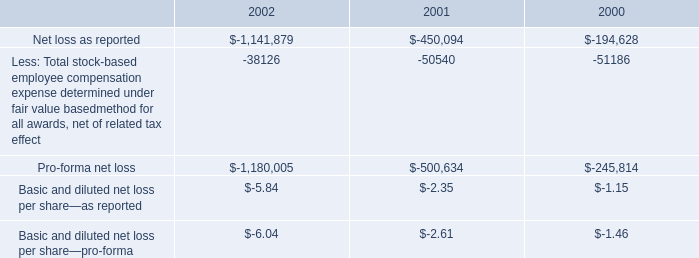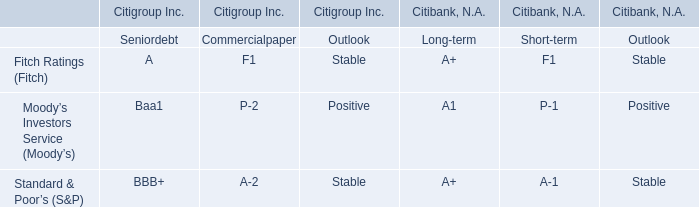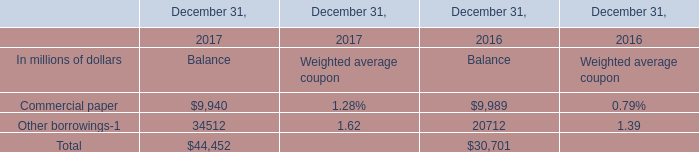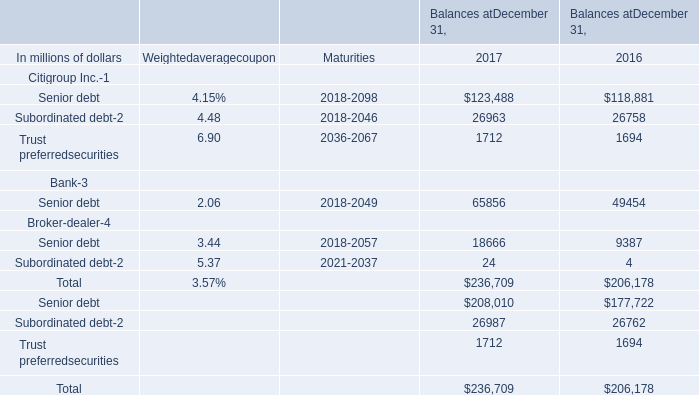what is the percentage change in 401 ( k ) contributions from 2000 to 2001? 
Computations: ((1540000 - 1593000) / 1593000)
Answer: -0.03327. 